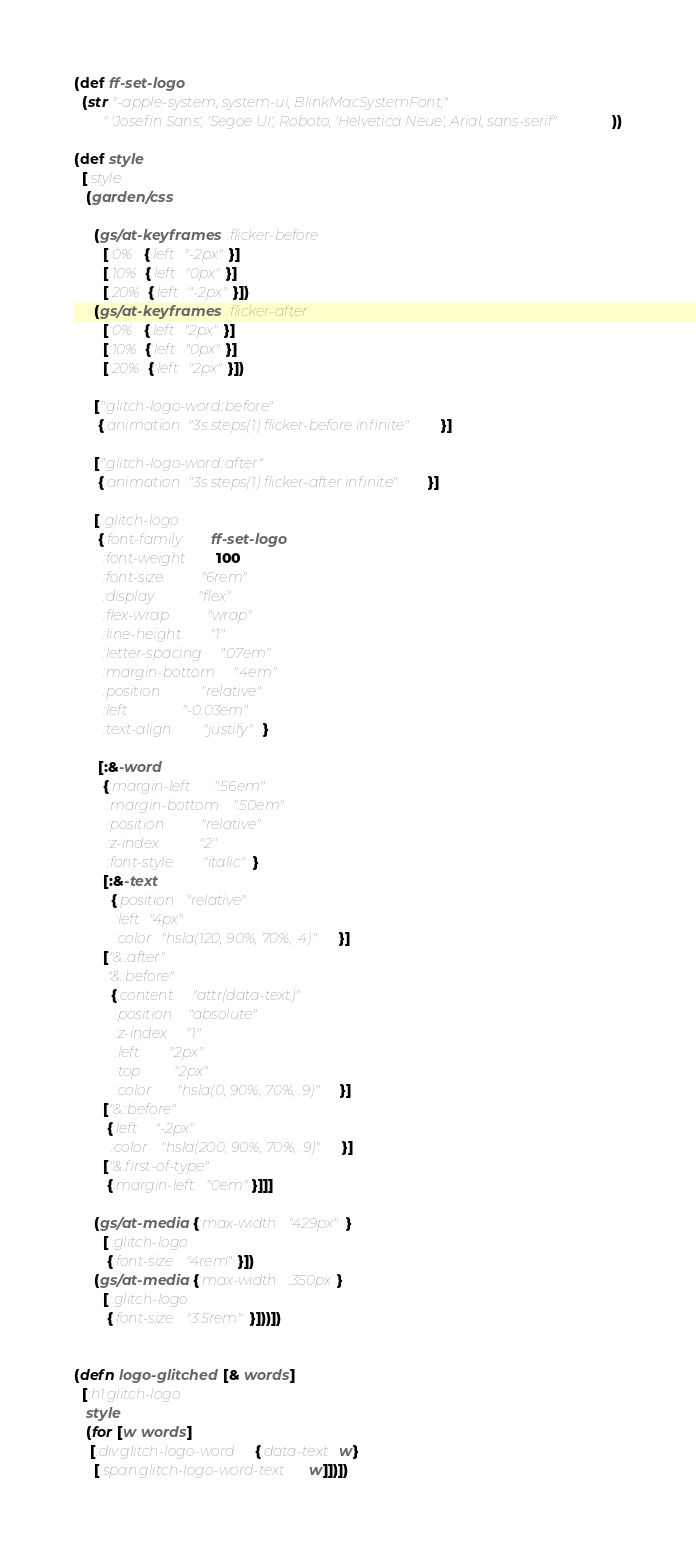<code> <loc_0><loc_0><loc_500><loc_500><_Clojure_>
(def ff-set-logo
  (str "-apple-system, system-ui, BlinkMacSystemFont,"
       " 'Josefin Sans', 'Segoe UI', Roboto, 'Helvetica Neue', Arial, sans-serif"))

(def style
  [:style
   (garden/css

     (gs/at-keyframes :flicker-before
       [:0%  {:left "-2px"}]
       [:10% {:left "0px"}]
       [:20% {:left "-2px"}])
     (gs/at-keyframes :flicker-after
       [:0%  {:left "2px"}]
       [:10% {:left "0px"}]
       [:20% {:left "2px"}])

     [".glitch-logo-word::before"
      {:animation "3s steps(1) flicker-before infinite"}]

     [".glitch-logo-word::after"
      {:animation "3s steps(1) flicker-after infinite"}]

     [:.glitch-logo
      {:font-family     ff-set-logo
       :font-weight     100
       :font-size       "6rem"
       :display         "flex"
       :flex-wrap       "wrap"
       :line-height     "1"
       :letter-spacing  ".07em"
       :margin-bottom   ".4em"
       :position        "relative"
       :left            "-0.03em"
       :text-align      "justify"}

      [:&-word
       {:margin-left    ".56em"
        :margin-bottom  ".50em"
        :position       "relative"
        :z-index        "2"
        :font-style     "italic"}
       [:&-text
         {:position "relative"
          :left "4px"
          :color "hsla(120, 90%, 70%, .4)"}]
       ["&::after"
        "&::before"
         {:content   "attr(data-text)"
          :position  "absolute"
          :z-index   "1"
          :left      "2px"
          :top       "2px"
          :color     "hsla(0, 90%, 70%, .9)"}]
       ["&::before"
        {:left   "-2px"
         :color  "hsla(200, 90%, 70%, .9)"}]
       ["&:first-of-type"
        {:margin-left "0em"}]]]

     (gs/at-media {:max-width "429px"}
       [:.glitch-logo
        {:font-size "4rem"}])
     (gs/at-media {:max-width :350px}
       [:.glitch-logo
        {:font-size "3.5rem"}]))])


(defn logo-glitched [& words]
  [:h1.glitch-logo
   style
   (for [w words]
    [:div.glitch-logo-word {:data-text w}
     [:span.glitch-logo-word-text w]])])
</code> 